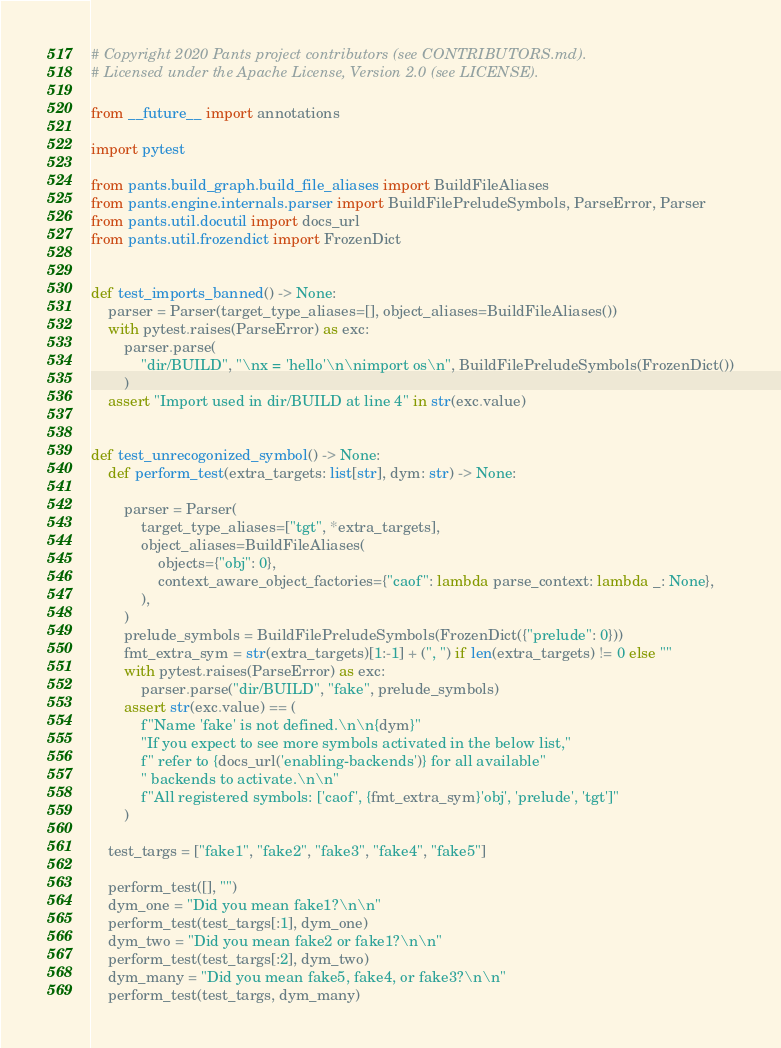<code> <loc_0><loc_0><loc_500><loc_500><_Python_># Copyright 2020 Pants project contributors (see CONTRIBUTORS.md).
# Licensed under the Apache License, Version 2.0 (see LICENSE).

from __future__ import annotations

import pytest

from pants.build_graph.build_file_aliases import BuildFileAliases
from pants.engine.internals.parser import BuildFilePreludeSymbols, ParseError, Parser
from pants.util.docutil import docs_url
from pants.util.frozendict import FrozenDict


def test_imports_banned() -> None:
    parser = Parser(target_type_aliases=[], object_aliases=BuildFileAliases())
    with pytest.raises(ParseError) as exc:
        parser.parse(
            "dir/BUILD", "\nx = 'hello'\n\nimport os\n", BuildFilePreludeSymbols(FrozenDict())
        )
    assert "Import used in dir/BUILD at line 4" in str(exc.value)


def test_unrecogonized_symbol() -> None:
    def perform_test(extra_targets: list[str], dym: str) -> None:

        parser = Parser(
            target_type_aliases=["tgt", *extra_targets],
            object_aliases=BuildFileAliases(
                objects={"obj": 0},
                context_aware_object_factories={"caof": lambda parse_context: lambda _: None},
            ),
        )
        prelude_symbols = BuildFilePreludeSymbols(FrozenDict({"prelude": 0}))
        fmt_extra_sym = str(extra_targets)[1:-1] + (", ") if len(extra_targets) != 0 else ""
        with pytest.raises(ParseError) as exc:
            parser.parse("dir/BUILD", "fake", prelude_symbols)
        assert str(exc.value) == (
            f"Name 'fake' is not defined.\n\n{dym}"
            "If you expect to see more symbols activated in the below list,"
            f" refer to {docs_url('enabling-backends')} for all available"
            " backends to activate.\n\n"
            f"All registered symbols: ['caof', {fmt_extra_sym}'obj', 'prelude', 'tgt']"
        )

    test_targs = ["fake1", "fake2", "fake3", "fake4", "fake5"]

    perform_test([], "")
    dym_one = "Did you mean fake1?\n\n"
    perform_test(test_targs[:1], dym_one)
    dym_two = "Did you mean fake2 or fake1?\n\n"
    perform_test(test_targs[:2], dym_two)
    dym_many = "Did you mean fake5, fake4, or fake3?\n\n"
    perform_test(test_targs, dym_many)
</code> 